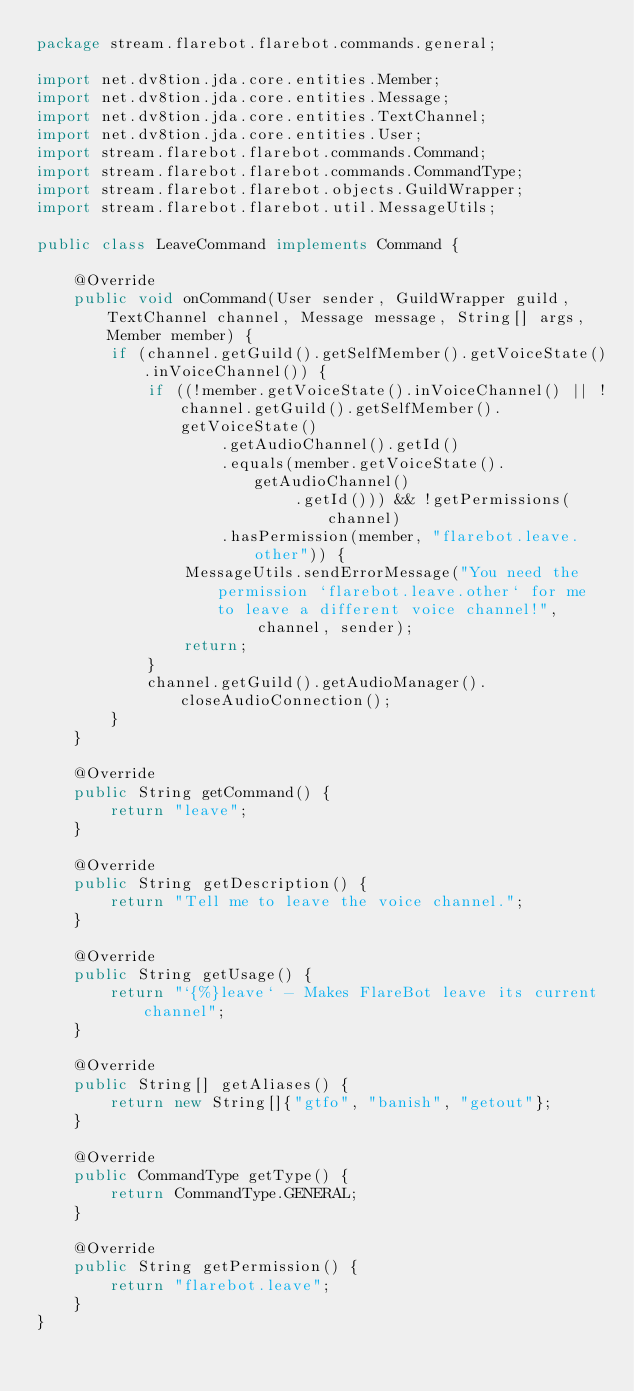Convert code to text. <code><loc_0><loc_0><loc_500><loc_500><_Java_>package stream.flarebot.flarebot.commands.general;

import net.dv8tion.jda.core.entities.Member;
import net.dv8tion.jda.core.entities.Message;
import net.dv8tion.jda.core.entities.TextChannel;
import net.dv8tion.jda.core.entities.User;
import stream.flarebot.flarebot.commands.Command;
import stream.flarebot.flarebot.commands.CommandType;
import stream.flarebot.flarebot.objects.GuildWrapper;
import stream.flarebot.flarebot.util.MessageUtils;

public class LeaveCommand implements Command {

    @Override
    public void onCommand(User sender, GuildWrapper guild, TextChannel channel, Message message, String[] args, Member member) {
        if (channel.getGuild().getSelfMember().getVoiceState().inVoiceChannel()) {
            if ((!member.getVoiceState().inVoiceChannel() || !channel.getGuild().getSelfMember().getVoiceState()
                    .getAudioChannel().getId()
                    .equals(member.getVoiceState().getAudioChannel()
                            .getId())) && !getPermissions(channel)
                    .hasPermission(member, "flarebot.leave.other")) {
                MessageUtils.sendErrorMessage("You need the permission `flarebot.leave.other` for me to leave a different voice channel!",
                        channel, sender);
                return;
            }
            channel.getGuild().getAudioManager().closeAudioConnection();
        }
    }

    @Override
    public String getCommand() {
        return "leave";
    }

    @Override
    public String getDescription() {
        return "Tell me to leave the voice channel.";
    }

    @Override
    public String getUsage() {
        return "`{%}leave` - Makes FlareBot leave its current channel";
    }

    @Override
    public String[] getAliases() {
        return new String[]{"gtfo", "banish", "getout"};
    }

    @Override
    public CommandType getType() {
        return CommandType.GENERAL;
    }

    @Override
    public String getPermission() {
        return "flarebot.leave";
    }
}
</code> 